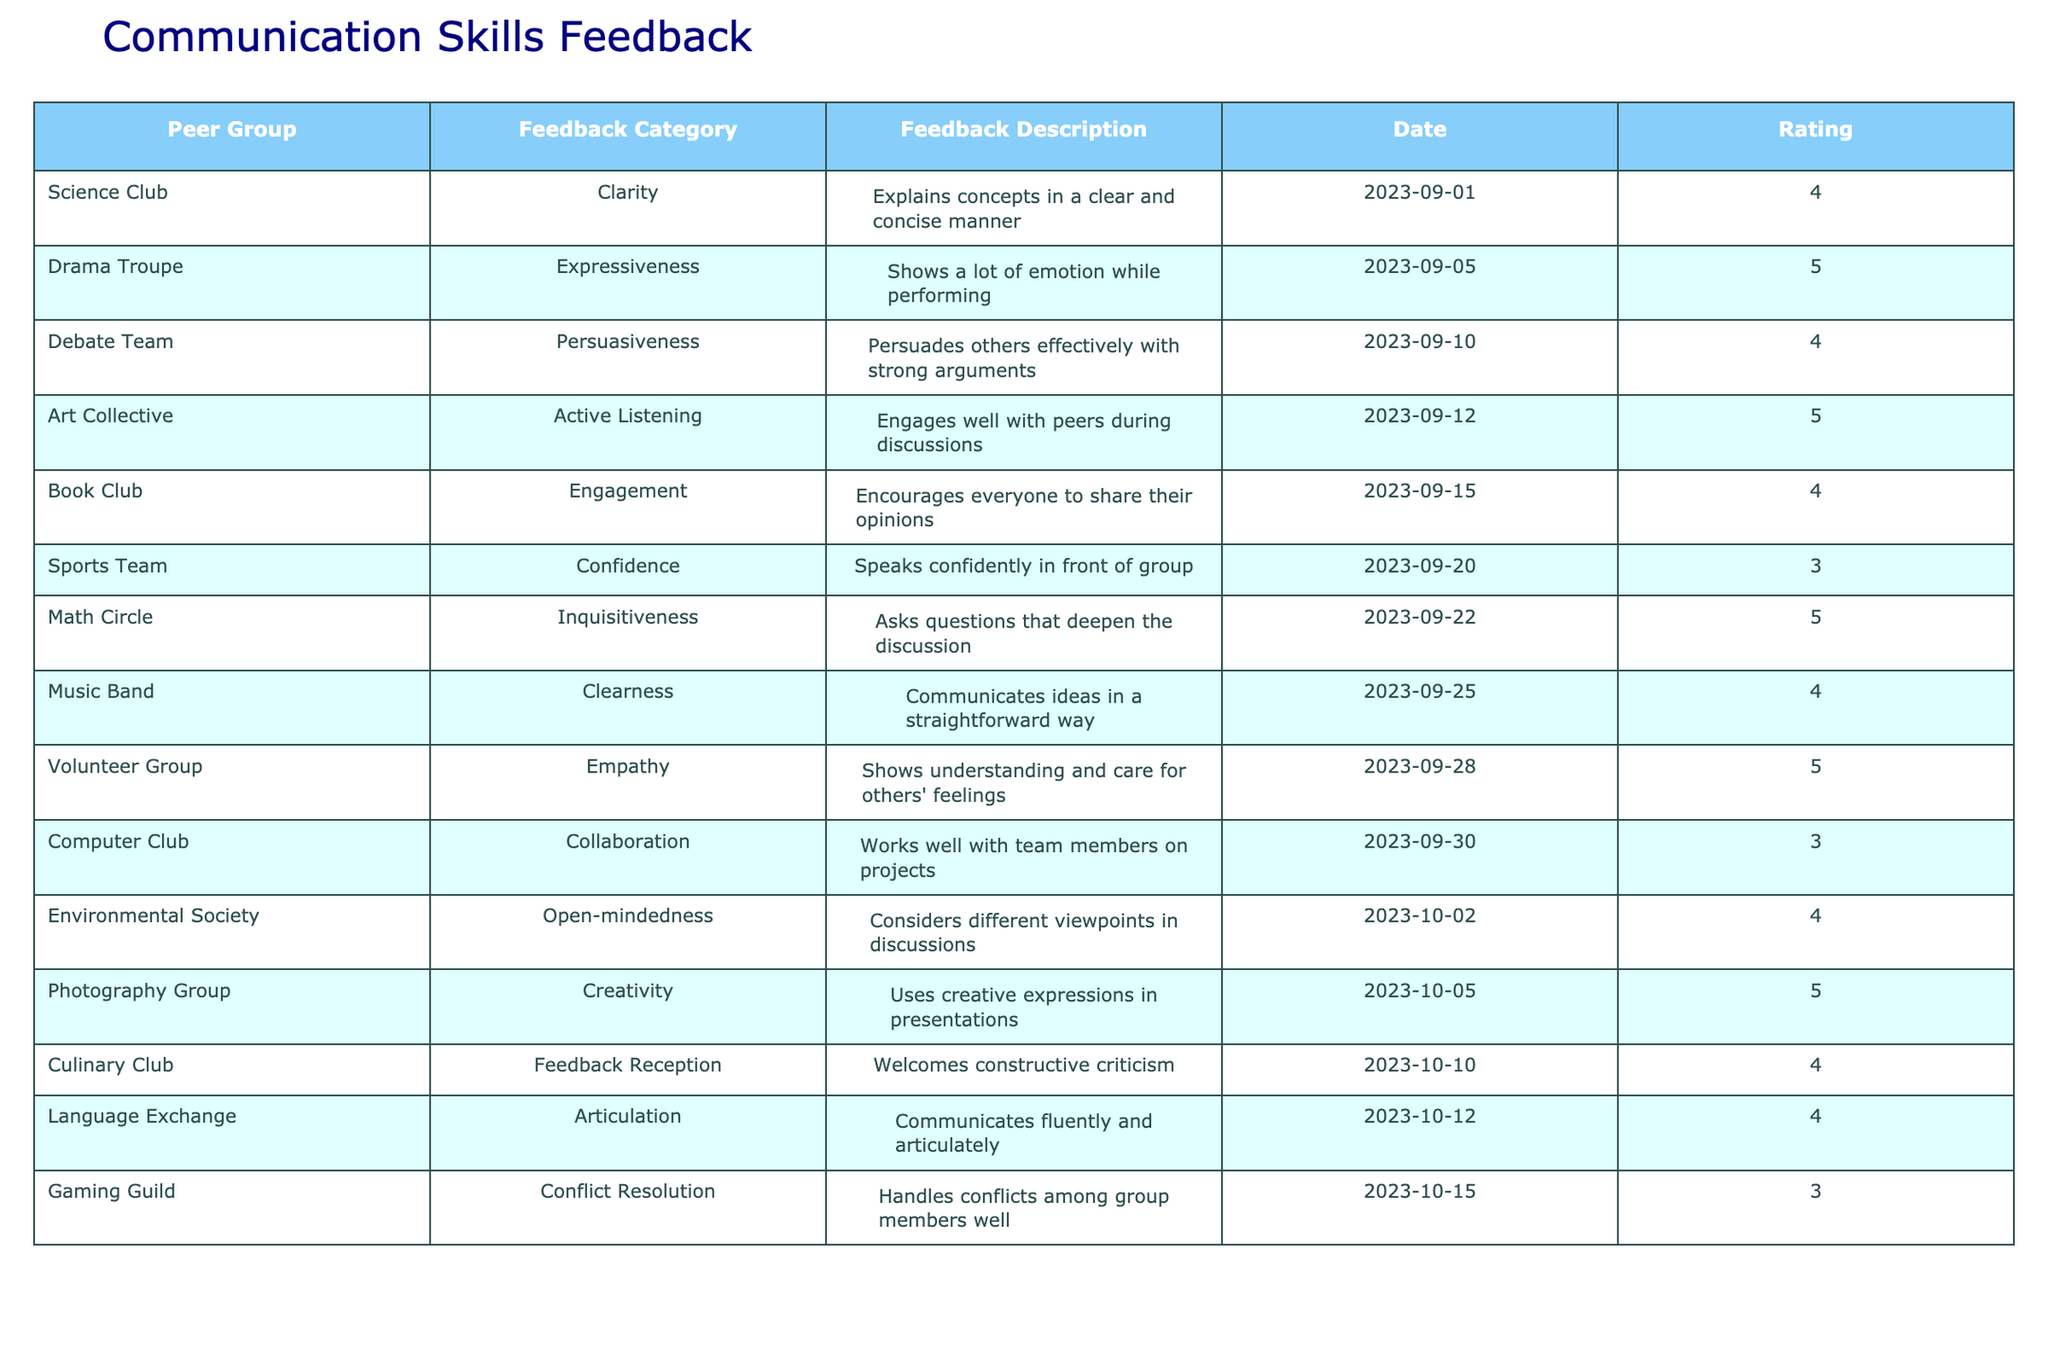What feedback category received the highest rating? Looking at the table, the feedback categories with the ratings are Expressiveness (5), Active Listening (5), Empathy (5), Inquisitiveness (5), Creativity (5). Therefore, multiple categories have the highest rating of 5.
Answer: Multiple categories have a rating of 5 Which peer group gave feedback on articulation? The table shows that the Language Exchange peer group has a feedback category for articulation.
Answer: Language Exchange What is the average rating of the feedback from the Sports Team and Computer Club? The Sports Team has a rating of 3 and the Computer Club has a rating of 3. Adding these ratings gives 3 + 3 = 6, and dividing by 2 (the number of ratings) results in an average of 3.
Answer: 3 Did the Art Collective provide feedback with a rating of 4 or higher? The Art Collective received feedback with a rating of 5, which is higher than 4.
Answer: Yes How many peer groups received a rating of 4 or higher? By scanning the ratings, we find that the following groups received 4 or higher: Science Club (4), Drama Troupe (5), Debate Team (4), Art Collective (5), Book Club (4), Music Band (4), Environmental Society (4), Culinary Club (4), and Language Exchange (4). Counting these gives a total of 9 groups.
Answer: 9 What rating did the Gaming Guild receive? The table shows that the Gaming Guild received a feedback rating of 3.
Answer: 3 Which feedback category has the lowest rating? The ratings for each category are as follows: 4, 5, 4, 5, 4, 3, 5, 4, 5, 3, 4, 5, 4, 3. The lowest rating is 3, which applies to both the Sports Team and Gaming Guild.
Answer: 3 What is the difference between the highest and lowest feedback ratings? The highest rating is 5 and the lowest rating is 3. The difference is calculated as 5 - 3 = 2.
Answer: 2 Which peer group communicated ideas in a clear way? The Music Band is noted for communicating ideas in a straightforward way, according to the feedback description.
Answer: Music Band Which three peer groups received the same rating of 4? The table shows several peer groups with a rating of 4: Science Club, Debate Team, Book Club, Music Band, Environmental Society, Culinary Club, and Language Exchange. Selecting three of these groups includes Science Club, Debate Team, and Book Club.
Answer: Science Club, Debate Team, Book Club 